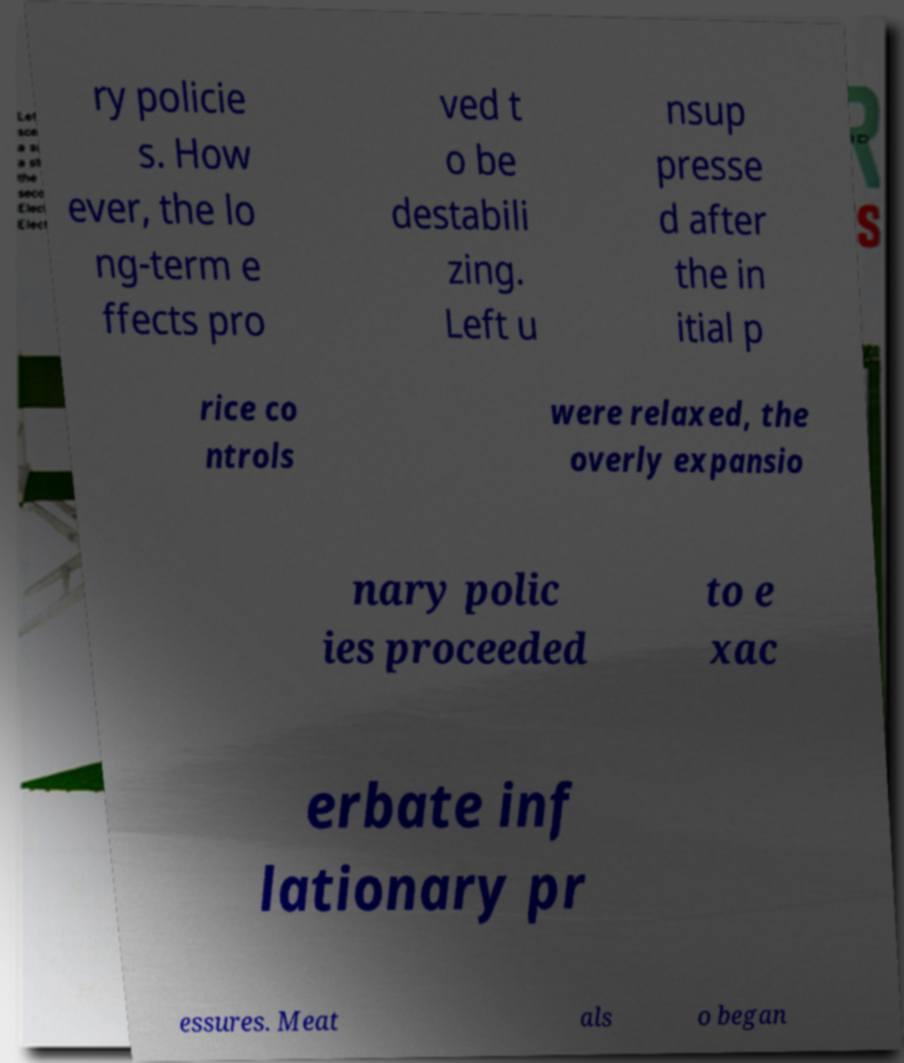I need the written content from this picture converted into text. Can you do that? ry policie s. How ever, the lo ng-term e ffects pro ved t o be destabili zing. Left u nsup presse d after the in itial p rice co ntrols were relaxed, the overly expansio nary polic ies proceeded to e xac erbate inf lationary pr essures. Meat als o began 